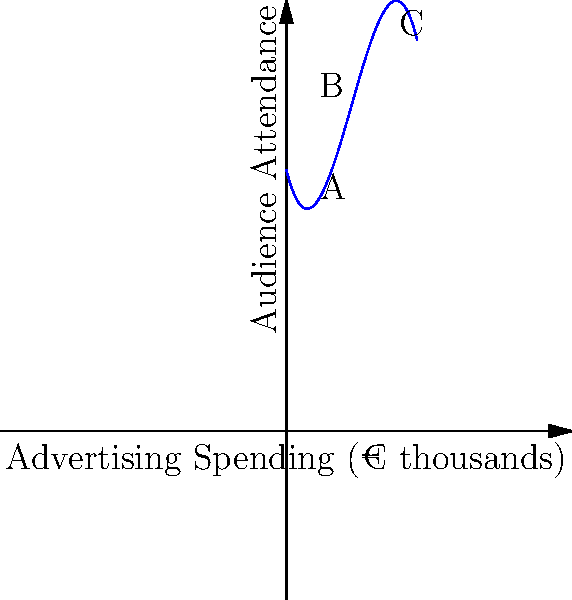As a small town theater owner in Italy, you're analyzing the relationship between advertising spending and audience attendance. The polynomial graph above represents this relationship. At which point (A, B, or C) does the marginal benefit of increased advertising spending start to diminish? To determine where the marginal benefit of increased advertising spending starts to diminish, we need to analyze the slope of the curve:

1. The slope represents the rate of change in audience attendance with respect to advertising spending.
2. A positive slope indicates increasing returns, while a decreasing positive slope or negative slope indicates diminishing returns.
3. Point A is on the steepest part of the curve, where the slope is highest and positive.
4. Point B is near the top of the curve, where the slope is still positive but less steep than at point A.
5. Point C is on the downward part of the curve, where the slope is negative.

The marginal benefit starts to diminish when the slope of the curve begins to decrease while still remaining positive. This occurs after point A and before point B.

Therefore, point B represents the position where the marginal benefit of increased advertising spending has already started to diminish.
Answer: B 